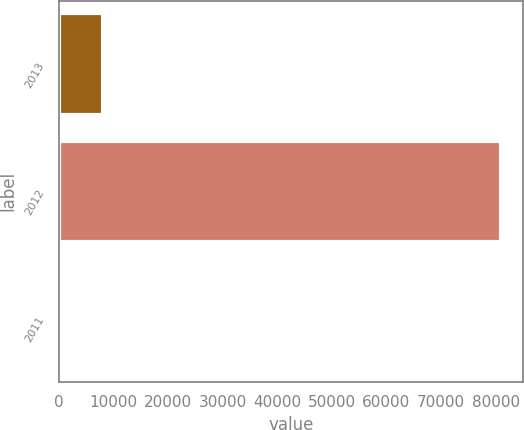Convert chart to OTSL. <chart><loc_0><loc_0><loc_500><loc_500><bar_chart><fcel>2013<fcel>2012<fcel>2011<nl><fcel>8154.1<fcel>80974<fcel>63<nl></chart> 